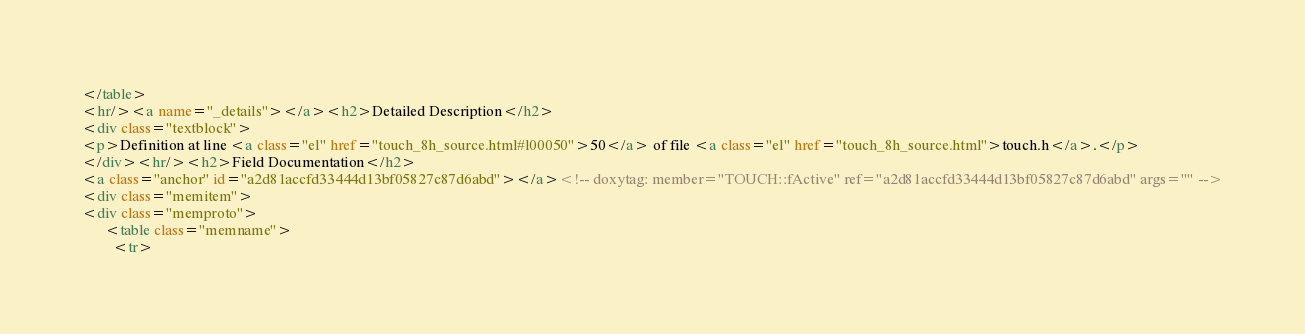<code> <loc_0><loc_0><loc_500><loc_500><_HTML_></table>
<hr/><a name="_details"></a><h2>Detailed Description</h2>
<div class="textblock">
<p>Definition at line <a class="el" href="touch_8h_source.html#l00050">50</a> of file <a class="el" href="touch_8h_source.html">touch.h</a>.</p>
</div><hr/><h2>Field Documentation</h2>
<a class="anchor" id="a2d81accfd33444d13bf05827c87d6abd"></a><!-- doxytag: member="TOUCH::fActive" ref="a2d81accfd33444d13bf05827c87d6abd" args="" -->
<div class="memitem">
<div class="memproto">
      <table class="memname">
        <tr></code> 